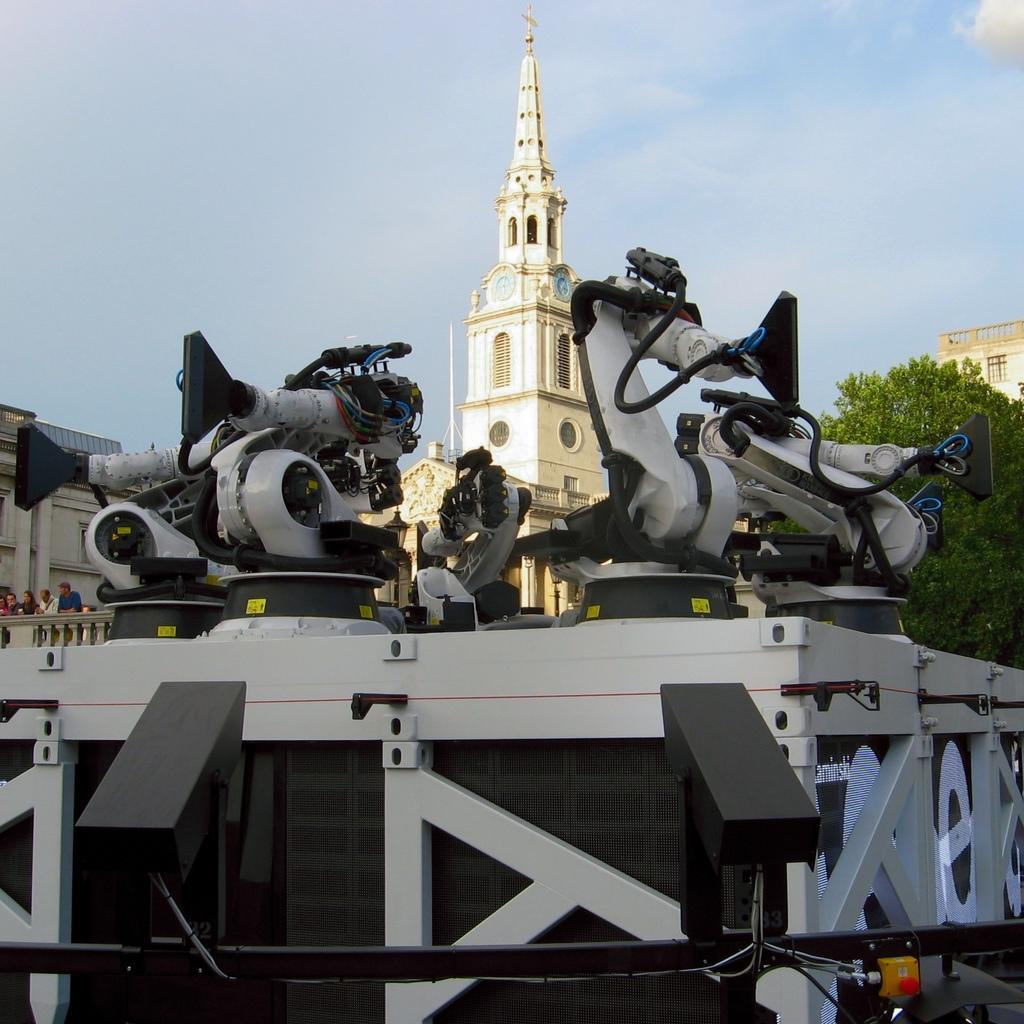How would you summarize this image in a sentence or two? In this picture there are few machines placed on an object and there are buildings and a tree in the background and there are few people standing in the left corner. 